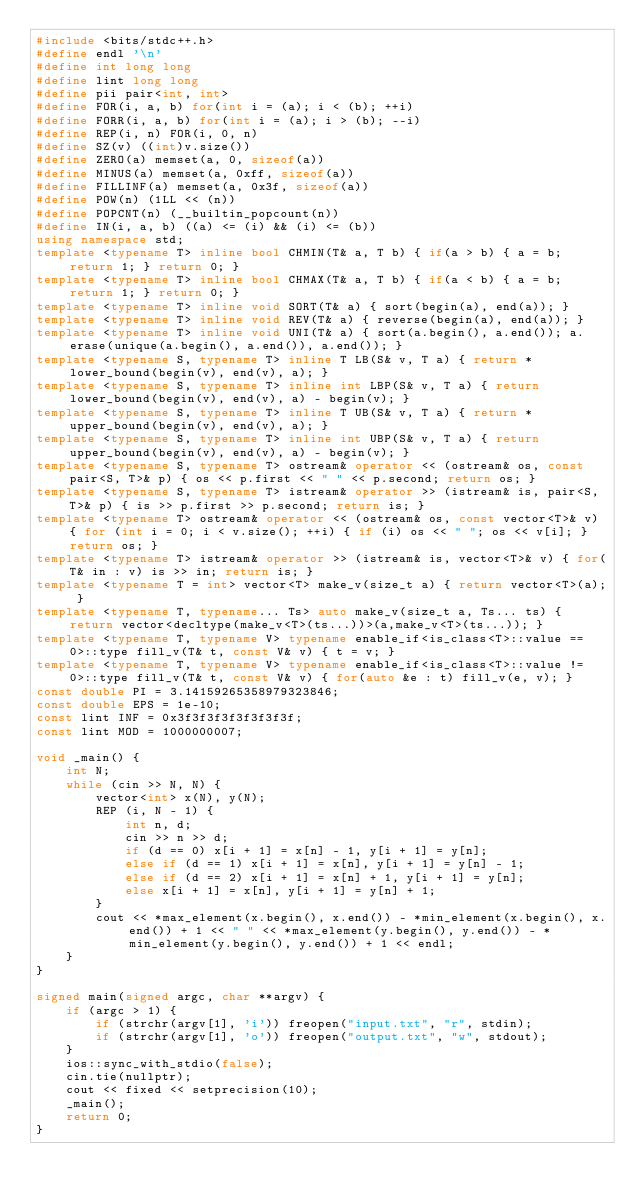Convert code to text. <code><loc_0><loc_0><loc_500><loc_500><_C++_>#include <bits/stdc++.h>
#define endl '\n'
#define int long long
#define lint long long
#define pii pair<int, int>
#define FOR(i, a, b) for(int i = (a); i < (b); ++i)
#define FORR(i, a, b) for(int i = (a); i > (b); --i)
#define REP(i, n) FOR(i, 0, n)
#define SZ(v) ((int)v.size())
#define ZERO(a) memset(a, 0, sizeof(a))
#define MINUS(a) memset(a, 0xff, sizeof(a))
#define FILLINF(a) memset(a, 0x3f, sizeof(a))
#define POW(n) (1LL << (n))
#define POPCNT(n) (__builtin_popcount(n))
#define IN(i, a, b) ((a) <= (i) && (i) <= (b))
using namespace std;
template <typename T> inline bool CHMIN(T& a, T b) { if(a > b) { a = b; return 1; } return 0; }
template <typename T> inline bool CHMAX(T& a, T b) { if(a < b) { a = b; return 1; } return 0; }
template <typename T> inline void SORT(T& a) { sort(begin(a), end(a)); }
template <typename T> inline void REV(T& a) { reverse(begin(a), end(a)); }
template <typename T> inline void UNI(T& a) { sort(a.begin(), a.end()); a.erase(unique(a.begin(), a.end()), a.end()); }
template <typename S, typename T> inline T LB(S& v, T a) { return *lower_bound(begin(v), end(v), a); }
template <typename S, typename T> inline int LBP(S& v, T a) { return lower_bound(begin(v), end(v), a) - begin(v); }
template <typename S, typename T> inline T UB(S& v, T a) { return *upper_bound(begin(v), end(v), a); }
template <typename S, typename T> inline int UBP(S& v, T a) { return upper_bound(begin(v), end(v), a) - begin(v); }
template <typename S, typename T> ostream& operator << (ostream& os, const pair<S, T>& p) { os << p.first << " " << p.second; return os; }
template <typename S, typename T> istream& operator >> (istream& is, pair<S, T>& p) { is >> p.first >> p.second; return is; }
template <typename T> ostream& operator << (ostream& os, const vector<T>& v) { for (int i = 0; i < v.size(); ++i) { if (i) os << " "; os << v[i]; } return os; }
template <typename T> istream& operator >> (istream& is, vector<T>& v) { for(T& in : v) is >> in; return is; }
template <typename T = int> vector<T> make_v(size_t a) { return vector<T>(a); }
template <typename T, typename... Ts> auto make_v(size_t a, Ts... ts) { return vector<decltype(make_v<T>(ts...))>(a,make_v<T>(ts...)); }
template <typename T, typename V> typename enable_if<is_class<T>::value == 0>::type fill_v(T& t, const V& v) { t = v; }
template <typename T, typename V> typename enable_if<is_class<T>::value != 0>::type fill_v(T& t, const V& v) { for(auto &e : t) fill_v(e, v); }
const double PI = 3.14159265358979323846;
const double EPS = 1e-10;
const lint INF = 0x3f3f3f3f3f3f3f3f;
const lint MOD = 1000000007;

void _main() {
    int N;
    while (cin >> N, N) {
        vector<int> x(N), y(N);
        REP (i, N - 1) {
            int n, d;
            cin >> n >> d;
            if (d == 0) x[i + 1] = x[n] - 1, y[i + 1] = y[n];
            else if (d == 1) x[i + 1] = x[n], y[i + 1] = y[n] - 1;
            else if (d == 2) x[i + 1] = x[n] + 1, y[i + 1] = y[n];
            else x[i + 1] = x[n], y[i + 1] = y[n] + 1;
        }
        cout << *max_element(x.begin(), x.end()) - *min_element(x.begin(), x.end()) + 1 << " " << *max_element(y.begin(), y.end()) - *min_element(y.begin(), y.end()) + 1 << endl;
    }
}

signed main(signed argc, char **argv) {
    if (argc > 1) {
        if (strchr(argv[1], 'i')) freopen("input.txt", "r", stdin);
        if (strchr(argv[1], 'o')) freopen("output.txt", "w", stdout);
    }
    ios::sync_with_stdio(false);
    cin.tie(nullptr);
    cout << fixed << setprecision(10);
    _main();
    return 0;
}
</code> 